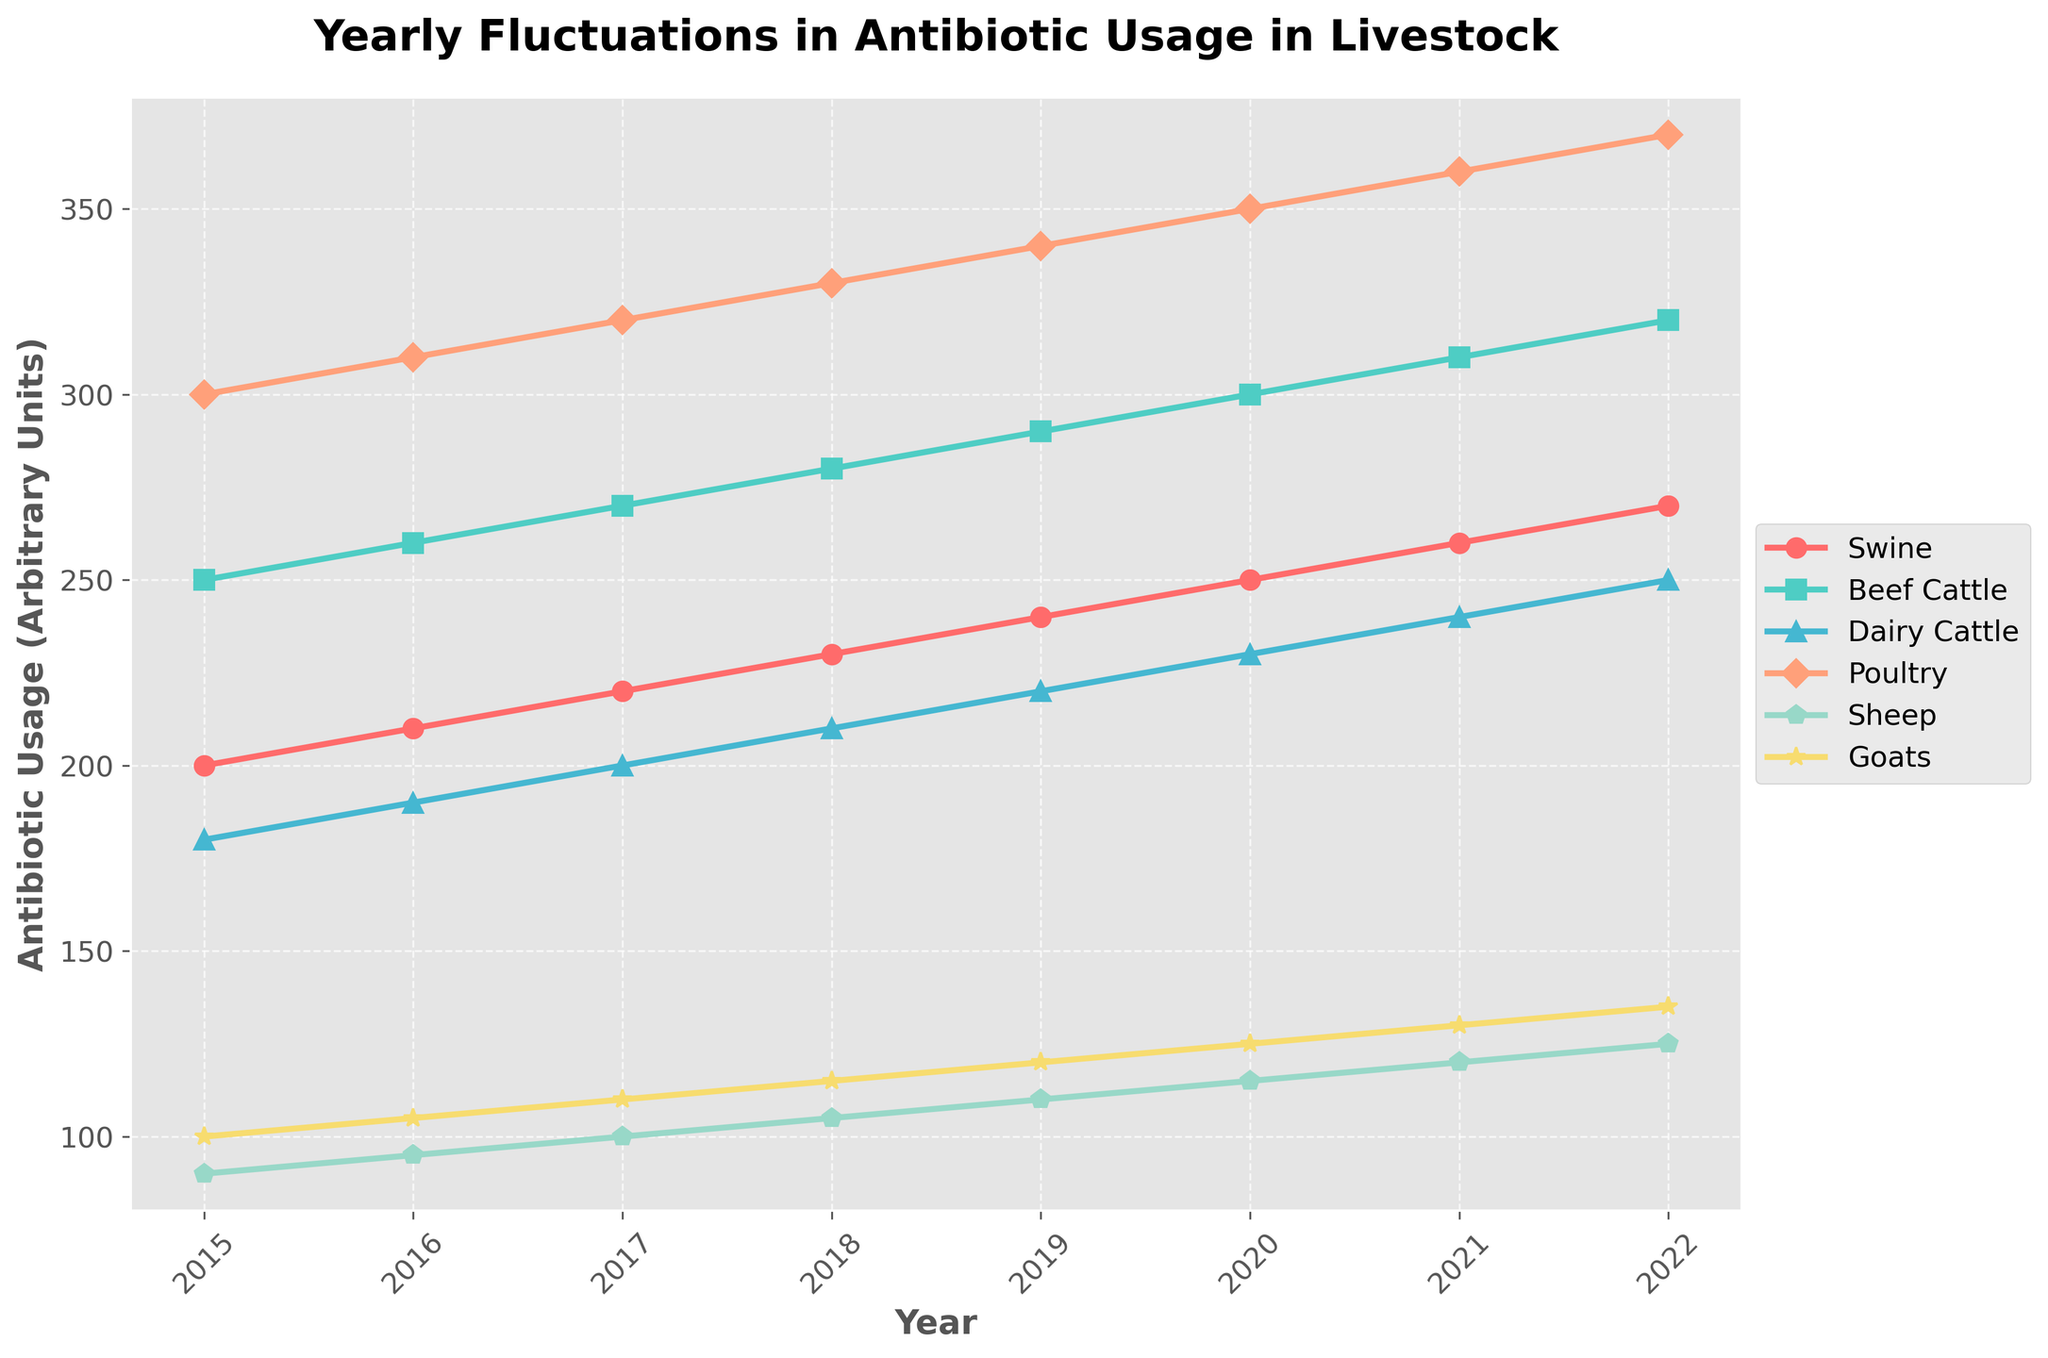What's the title of the plot? The title of the plot is generally located at the top. It summarizes the content of the plot and helps set the context for the visualized data. Here, it says "Yearly Fluctuations in Antibiotic Usage in Livestock".
Answer: Yearly Fluctuations in Antibiotic Usage in Livestock What is the range of years displayed on the x-axis? The x-axis represents time, specifically years. By looking at the start and end points of the x-axis, you can determine the range. The x-axis starts at 2015 and ends at 2022.
Answer: 2015 to 2022 Which livestock category shows the highest antibiotic usage in 2020? To find this, track the values along the y-axis for the year 2020 for each livestock category. The category with the highest y-value represents the highest antibiotic usage. In 2020, Poultry shows the highest value at 350 units.
Answer: Poultry How has antibiotic usage in Swine changed from 2015 to 2022? To determine the change, subtract the 2015 value from the 2022 value for Swine. Swine usage was 200 in 2015 and 270 in 2022. 270 - 200 = 70.
Answer: Increased by 70 units Which category shows the least growth in antibiotic usage over the years? This involves calculating the difference in values from 2015 to 2022 for each category and identifying the smallest difference. Sheep grows from 90 to 125, an increase of 35 units, the least among all categories.
Answer: Sheep On which year do Beef Cattle and Swine have the same antibiotic usage? Check the data points visually for both categories year by year and find when they converge to the same value. In 2016, Beef Cattle and Swine both use 210 units.
Answer: 2016 What is the average antibiotic usage for Dairy Cattle between 2015 and 2022? Sum the values for Dairy Cattle from 2015 to 2022 and then divide by the number of years. (180 + 190 + 200 + 210 + 220 + 230 + 240 + 250) / 8 = 215.
Answer: 215 units Compare the antibiotic usage for Goats and Sheep in 2017. Which had more usage? Look at the 2017 data points for both Goats and Sheep. Goats have 110 units, and Sheep have 100 units. Thus, Goats have more.
Answer: Goats Which livestock category has a consistent increase in antibiotic usage each year? Consistency means no drops in values across the years. By examining each line on the plot visually, we see all categories show a steady increase each year.
Answer: All categories What is the total antibiotic usage for Poultry from 2015 to 2022? Sum the yearly values for Poultry from 2015 to 2022: 300 + 310 + 320 + 330 + 340 + 350 + 360 + 370 = 2680.
Answer: 2680 units 